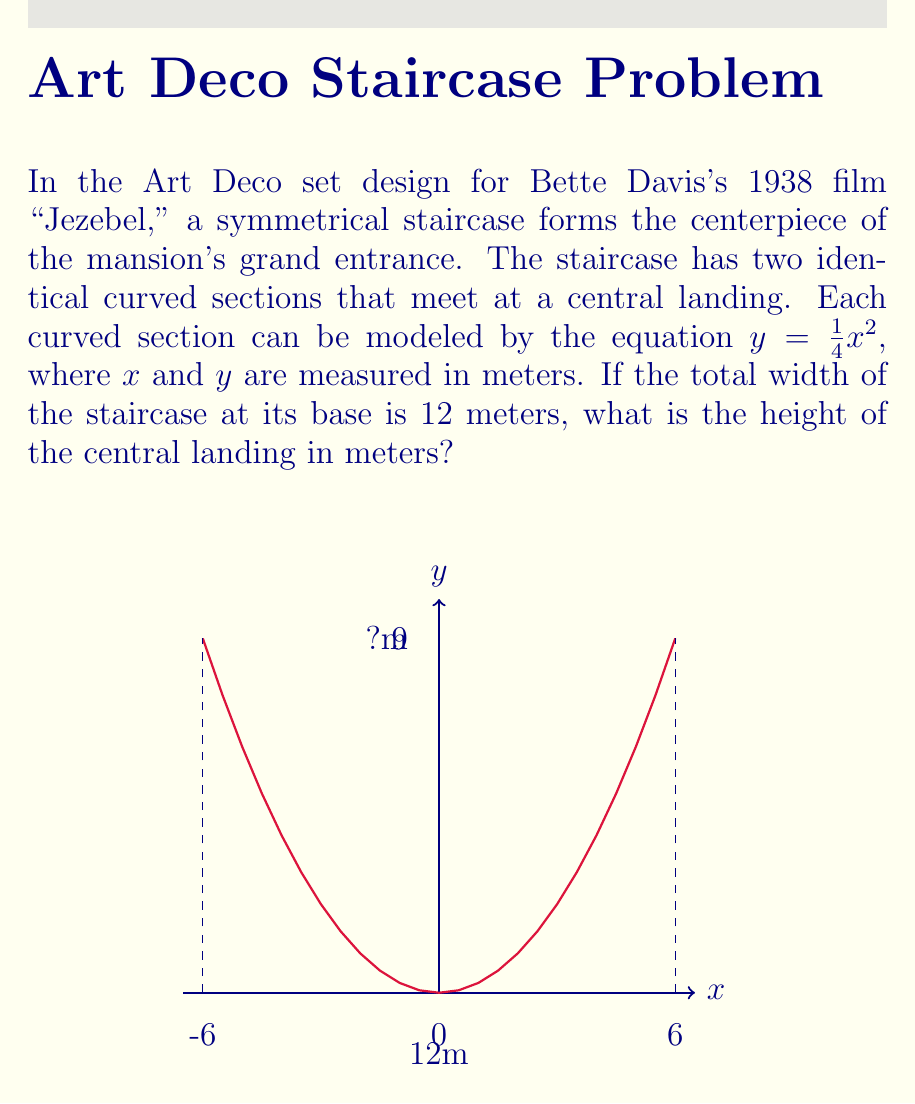Can you solve this math problem? Let's approach this step-by-step:

1) The equation for each curved section is $y = \frac{1}{4}x^2$.

2) The total width of the staircase is 12 meters. Since it's symmetrical, each curved section spans half of this width, which is 6 meters.

3) To find the height of the central landing, we need to calculate the y-value when x = 6 (half the total width).

4) Substituting x = 6 into the equation:

   $y = \frac{1}{4}(6)^2$

5) Simplify:
   $y = \frac{1}{4}(36)$
   $y = 9$

6) Therefore, the height of the central landing is 9 meters.

This Art Deco design, reminiscent of the grand staircases seen in many Bette Davis films, showcases the symmetry and proportions typical of 1930s Hollywood set designs. The parabolic curve creates an elegant, sweeping effect that would have been visually striking on the silver screen.
Answer: 9 meters 